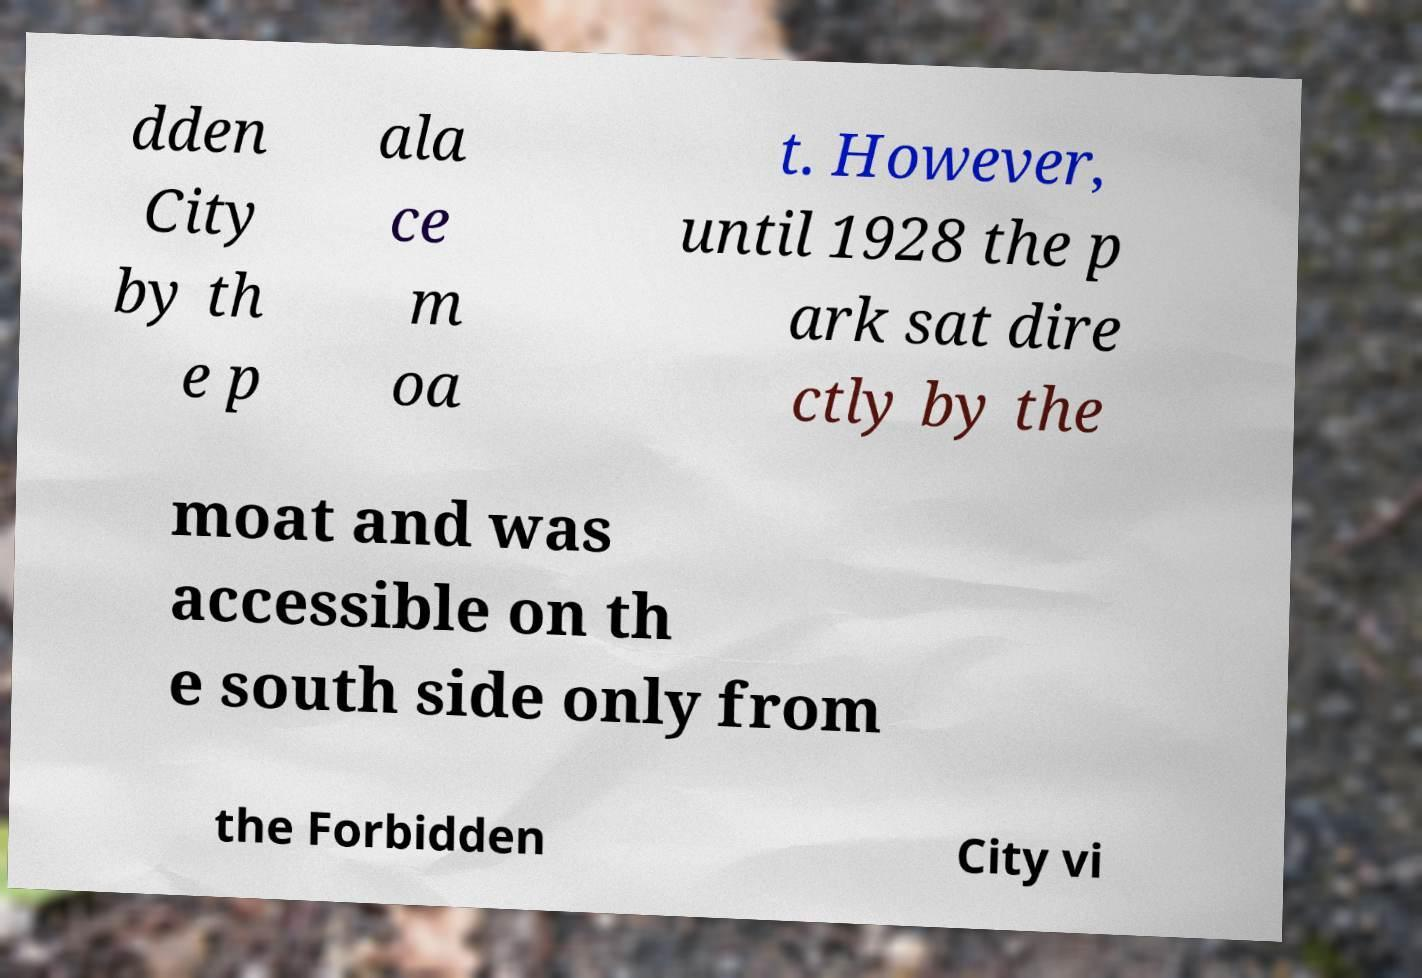Please read and relay the text visible in this image. What does it say? dden City by th e p ala ce m oa t. However, until 1928 the p ark sat dire ctly by the moat and was accessible on th e south side only from the Forbidden City vi 